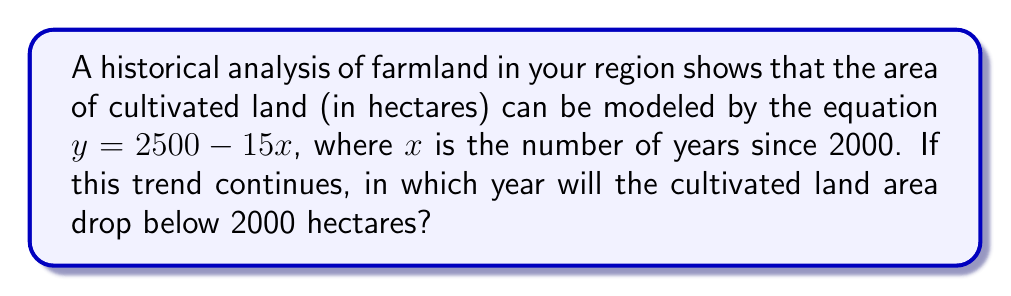Could you help me with this problem? To solve this problem, we'll follow these steps:

1) We need to find $x$ when $y = 2000$ hectares.

2) Substitute $y = 2000$ into the equation:
   $2000 = 2500 - 15x$

3) Subtract 2500 from both sides:
   $-500 = -15x$

4) Divide both sides by -15:
   $\frac{-500}{-15} = x$
   $33.33 = x$

5) Since $x$ represents the number of years since 2000, we need to add this to 2000:
   $2000 + 33.33 = 2033.33$

6) As we're dealing with whole years, we round up to 2034, because the area will drop below 2000 hectares during this year.
Answer: 2034 